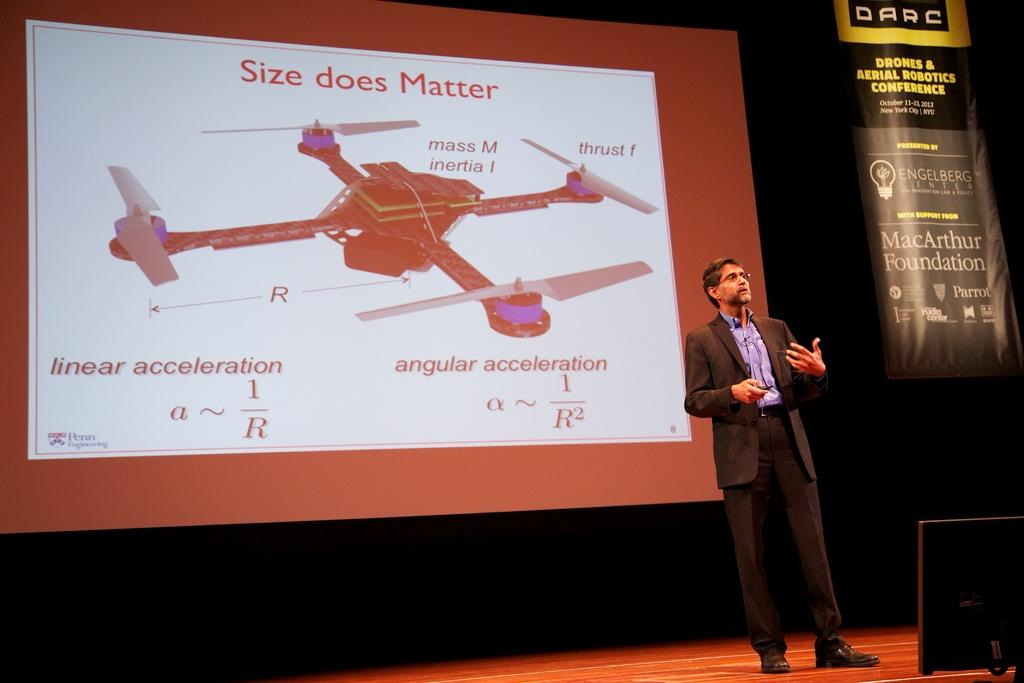<image>
Give a short and clear explanation of the subsequent image. A man stands in front of a screen, which is displaying a slide entitled Size does Matter. 